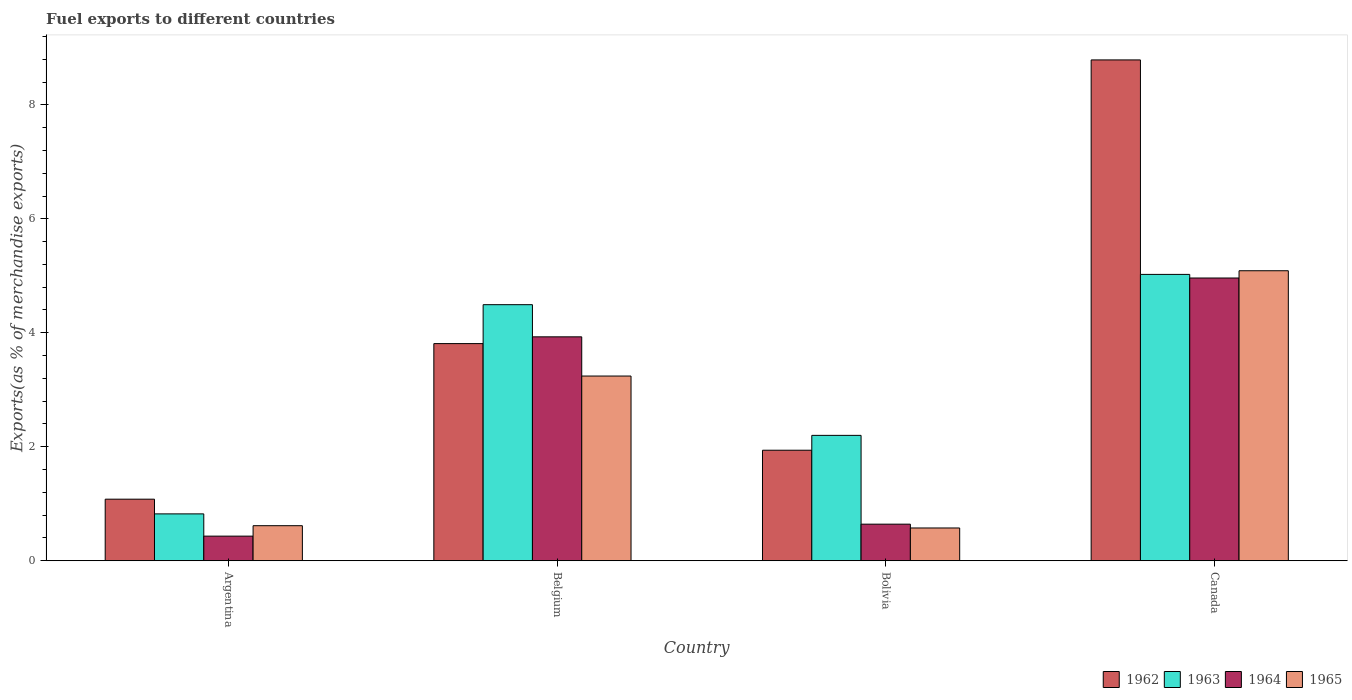How many different coloured bars are there?
Offer a terse response. 4. Are the number of bars per tick equal to the number of legend labels?
Make the answer very short. Yes. Are the number of bars on each tick of the X-axis equal?
Keep it short and to the point. Yes. How many bars are there on the 1st tick from the right?
Provide a succinct answer. 4. What is the percentage of exports to different countries in 1964 in Belgium?
Make the answer very short. 3.93. Across all countries, what is the maximum percentage of exports to different countries in 1963?
Your answer should be very brief. 5.02. Across all countries, what is the minimum percentage of exports to different countries in 1964?
Give a very brief answer. 0.43. In which country was the percentage of exports to different countries in 1964 minimum?
Provide a succinct answer. Argentina. What is the total percentage of exports to different countries in 1965 in the graph?
Your response must be concise. 9.52. What is the difference between the percentage of exports to different countries in 1962 in Argentina and that in Belgium?
Provide a succinct answer. -2.73. What is the difference between the percentage of exports to different countries in 1962 in Belgium and the percentage of exports to different countries in 1963 in Bolivia?
Your answer should be compact. 1.61. What is the average percentage of exports to different countries in 1964 per country?
Give a very brief answer. 2.49. What is the difference between the percentage of exports to different countries of/in 1962 and percentage of exports to different countries of/in 1963 in Bolivia?
Your answer should be compact. -0.26. What is the ratio of the percentage of exports to different countries in 1963 in Argentina to that in Bolivia?
Provide a succinct answer. 0.37. Is the percentage of exports to different countries in 1962 in Belgium less than that in Canada?
Offer a very short reply. Yes. What is the difference between the highest and the second highest percentage of exports to different countries in 1962?
Your response must be concise. 6.85. What is the difference between the highest and the lowest percentage of exports to different countries in 1963?
Your answer should be very brief. 4.2. In how many countries, is the percentage of exports to different countries in 1962 greater than the average percentage of exports to different countries in 1962 taken over all countries?
Make the answer very short. 1. Is the sum of the percentage of exports to different countries in 1965 in Argentina and Belgium greater than the maximum percentage of exports to different countries in 1964 across all countries?
Offer a terse response. No. Is it the case that in every country, the sum of the percentage of exports to different countries in 1964 and percentage of exports to different countries in 1962 is greater than the sum of percentage of exports to different countries in 1965 and percentage of exports to different countries in 1963?
Your answer should be compact. No. What does the 3rd bar from the left in Belgium represents?
Provide a succinct answer. 1964. What does the 2nd bar from the right in Bolivia represents?
Offer a terse response. 1964. Is it the case that in every country, the sum of the percentage of exports to different countries in 1962 and percentage of exports to different countries in 1965 is greater than the percentage of exports to different countries in 1964?
Your answer should be compact. Yes. How many bars are there?
Your answer should be compact. 16. Are all the bars in the graph horizontal?
Give a very brief answer. No. How many countries are there in the graph?
Offer a very short reply. 4. What is the difference between two consecutive major ticks on the Y-axis?
Keep it short and to the point. 2. Are the values on the major ticks of Y-axis written in scientific E-notation?
Your response must be concise. No. Does the graph contain grids?
Offer a very short reply. No. How many legend labels are there?
Provide a short and direct response. 4. How are the legend labels stacked?
Provide a short and direct response. Horizontal. What is the title of the graph?
Give a very brief answer. Fuel exports to different countries. What is the label or title of the X-axis?
Your answer should be compact. Country. What is the label or title of the Y-axis?
Ensure brevity in your answer.  Exports(as % of merchandise exports). What is the Exports(as % of merchandise exports) in 1962 in Argentina?
Provide a short and direct response. 1.08. What is the Exports(as % of merchandise exports) in 1963 in Argentina?
Your response must be concise. 0.82. What is the Exports(as % of merchandise exports) of 1964 in Argentina?
Ensure brevity in your answer.  0.43. What is the Exports(as % of merchandise exports) of 1965 in Argentina?
Keep it short and to the point. 0.62. What is the Exports(as % of merchandise exports) of 1962 in Belgium?
Keep it short and to the point. 3.81. What is the Exports(as % of merchandise exports) of 1963 in Belgium?
Provide a succinct answer. 4.49. What is the Exports(as % of merchandise exports) in 1964 in Belgium?
Give a very brief answer. 3.93. What is the Exports(as % of merchandise exports) in 1965 in Belgium?
Make the answer very short. 3.24. What is the Exports(as % of merchandise exports) in 1962 in Bolivia?
Provide a succinct answer. 1.94. What is the Exports(as % of merchandise exports) in 1963 in Bolivia?
Your answer should be very brief. 2.2. What is the Exports(as % of merchandise exports) of 1964 in Bolivia?
Your answer should be compact. 0.64. What is the Exports(as % of merchandise exports) in 1965 in Bolivia?
Provide a short and direct response. 0.58. What is the Exports(as % of merchandise exports) in 1962 in Canada?
Provide a short and direct response. 8.79. What is the Exports(as % of merchandise exports) of 1963 in Canada?
Provide a short and direct response. 5.02. What is the Exports(as % of merchandise exports) in 1964 in Canada?
Provide a succinct answer. 4.96. What is the Exports(as % of merchandise exports) in 1965 in Canada?
Provide a succinct answer. 5.09. Across all countries, what is the maximum Exports(as % of merchandise exports) of 1962?
Give a very brief answer. 8.79. Across all countries, what is the maximum Exports(as % of merchandise exports) in 1963?
Offer a terse response. 5.02. Across all countries, what is the maximum Exports(as % of merchandise exports) in 1964?
Your answer should be very brief. 4.96. Across all countries, what is the maximum Exports(as % of merchandise exports) of 1965?
Make the answer very short. 5.09. Across all countries, what is the minimum Exports(as % of merchandise exports) of 1962?
Provide a succinct answer. 1.08. Across all countries, what is the minimum Exports(as % of merchandise exports) of 1963?
Provide a short and direct response. 0.82. Across all countries, what is the minimum Exports(as % of merchandise exports) in 1964?
Offer a very short reply. 0.43. Across all countries, what is the minimum Exports(as % of merchandise exports) of 1965?
Offer a very short reply. 0.58. What is the total Exports(as % of merchandise exports) of 1962 in the graph?
Ensure brevity in your answer.  15.62. What is the total Exports(as % of merchandise exports) in 1963 in the graph?
Provide a short and direct response. 12.54. What is the total Exports(as % of merchandise exports) in 1964 in the graph?
Offer a very short reply. 9.97. What is the total Exports(as % of merchandise exports) of 1965 in the graph?
Provide a succinct answer. 9.52. What is the difference between the Exports(as % of merchandise exports) of 1962 in Argentina and that in Belgium?
Offer a very short reply. -2.73. What is the difference between the Exports(as % of merchandise exports) of 1963 in Argentina and that in Belgium?
Your answer should be compact. -3.67. What is the difference between the Exports(as % of merchandise exports) of 1964 in Argentina and that in Belgium?
Provide a succinct answer. -3.5. What is the difference between the Exports(as % of merchandise exports) of 1965 in Argentina and that in Belgium?
Offer a terse response. -2.63. What is the difference between the Exports(as % of merchandise exports) in 1962 in Argentina and that in Bolivia?
Provide a succinct answer. -0.86. What is the difference between the Exports(as % of merchandise exports) in 1963 in Argentina and that in Bolivia?
Your answer should be compact. -1.38. What is the difference between the Exports(as % of merchandise exports) of 1964 in Argentina and that in Bolivia?
Offer a terse response. -0.21. What is the difference between the Exports(as % of merchandise exports) in 1965 in Argentina and that in Bolivia?
Give a very brief answer. 0.04. What is the difference between the Exports(as % of merchandise exports) in 1962 in Argentina and that in Canada?
Provide a succinct answer. -7.71. What is the difference between the Exports(as % of merchandise exports) of 1963 in Argentina and that in Canada?
Provide a short and direct response. -4.2. What is the difference between the Exports(as % of merchandise exports) of 1964 in Argentina and that in Canada?
Offer a very short reply. -4.53. What is the difference between the Exports(as % of merchandise exports) of 1965 in Argentina and that in Canada?
Your answer should be compact. -4.47. What is the difference between the Exports(as % of merchandise exports) in 1962 in Belgium and that in Bolivia?
Provide a short and direct response. 1.87. What is the difference between the Exports(as % of merchandise exports) of 1963 in Belgium and that in Bolivia?
Make the answer very short. 2.29. What is the difference between the Exports(as % of merchandise exports) of 1964 in Belgium and that in Bolivia?
Provide a short and direct response. 3.29. What is the difference between the Exports(as % of merchandise exports) of 1965 in Belgium and that in Bolivia?
Offer a terse response. 2.67. What is the difference between the Exports(as % of merchandise exports) in 1962 in Belgium and that in Canada?
Your response must be concise. -4.98. What is the difference between the Exports(as % of merchandise exports) of 1963 in Belgium and that in Canada?
Offer a terse response. -0.53. What is the difference between the Exports(as % of merchandise exports) of 1964 in Belgium and that in Canada?
Provide a short and direct response. -1.03. What is the difference between the Exports(as % of merchandise exports) in 1965 in Belgium and that in Canada?
Give a very brief answer. -1.85. What is the difference between the Exports(as % of merchandise exports) of 1962 in Bolivia and that in Canada?
Keep it short and to the point. -6.85. What is the difference between the Exports(as % of merchandise exports) of 1963 in Bolivia and that in Canada?
Ensure brevity in your answer.  -2.82. What is the difference between the Exports(as % of merchandise exports) of 1964 in Bolivia and that in Canada?
Give a very brief answer. -4.32. What is the difference between the Exports(as % of merchandise exports) of 1965 in Bolivia and that in Canada?
Offer a terse response. -4.51. What is the difference between the Exports(as % of merchandise exports) of 1962 in Argentina and the Exports(as % of merchandise exports) of 1963 in Belgium?
Provide a short and direct response. -3.41. What is the difference between the Exports(as % of merchandise exports) of 1962 in Argentina and the Exports(as % of merchandise exports) of 1964 in Belgium?
Keep it short and to the point. -2.85. What is the difference between the Exports(as % of merchandise exports) of 1962 in Argentina and the Exports(as % of merchandise exports) of 1965 in Belgium?
Keep it short and to the point. -2.16. What is the difference between the Exports(as % of merchandise exports) in 1963 in Argentina and the Exports(as % of merchandise exports) in 1964 in Belgium?
Ensure brevity in your answer.  -3.11. What is the difference between the Exports(as % of merchandise exports) in 1963 in Argentina and the Exports(as % of merchandise exports) in 1965 in Belgium?
Provide a succinct answer. -2.42. What is the difference between the Exports(as % of merchandise exports) of 1964 in Argentina and the Exports(as % of merchandise exports) of 1965 in Belgium?
Provide a succinct answer. -2.81. What is the difference between the Exports(as % of merchandise exports) in 1962 in Argentina and the Exports(as % of merchandise exports) in 1963 in Bolivia?
Offer a very short reply. -1.12. What is the difference between the Exports(as % of merchandise exports) in 1962 in Argentina and the Exports(as % of merchandise exports) in 1964 in Bolivia?
Give a very brief answer. 0.44. What is the difference between the Exports(as % of merchandise exports) in 1962 in Argentina and the Exports(as % of merchandise exports) in 1965 in Bolivia?
Your answer should be compact. 0.51. What is the difference between the Exports(as % of merchandise exports) of 1963 in Argentina and the Exports(as % of merchandise exports) of 1964 in Bolivia?
Keep it short and to the point. 0.18. What is the difference between the Exports(as % of merchandise exports) of 1963 in Argentina and the Exports(as % of merchandise exports) of 1965 in Bolivia?
Make the answer very short. 0.25. What is the difference between the Exports(as % of merchandise exports) of 1964 in Argentina and the Exports(as % of merchandise exports) of 1965 in Bolivia?
Give a very brief answer. -0.14. What is the difference between the Exports(as % of merchandise exports) of 1962 in Argentina and the Exports(as % of merchandise exports) of 1963 in Canada?
Make the answer very short. -3.94. What is the difference between the Exports(as % of merchandise exports) in 1962 in Argentina and the Exports(as % of merchandise exports) in 1964 in Canada?
Provide a short and direct response. -3.88. What is the difference between the Exports(as % of merchandise exports) in 1962 in Argentina and the Exports(as % of merchandise exports) in 1965 in Canada?
Offer a terse response. -4.01. What is the difference between the Exports(as % of merchandise exports) of 1963 in Argentina and the Exports(as % of merchandise exports) of 1964 in Canada?
Give a very brief answer. -4.14. What is the difference between the Exports(as % of merchandise exports) of 1963 in Argentina and the Exports(as % of merchandise exports) of 1965 in Canada?
Make the answer very short. -4.27. What is the difference between the Exports(as % of merchandise exports) in 1964 in Argentina and the Exports(as % of merchandise exports) in 1965 in Canada?
Make the answer very short. -4.66. What is the difference between the Exports(as % of merchandise exports) of 1962 in Belgium and the Exports(as % of merchandise exports) of 1963 in Bolivia?
Provide a short and direct response. 1.61. What is the difference between the Exports(as % of merchandise exports) in 1962 in Belgium and the Exports(as % of merchandise exports) in 1964 in Bolivia?
Your response must be concise. 3.17. What is the difference between the Exports(as % of merchandise exports) in 1962 in Belgium and the Exports(as % of merchandise exports) in 1965 in Bolivia?
Offer a very short reply. 3.23. What is the difference between the Exports(as % of merchandise exports) in 1963 in Belgium and the Exports(as % of merchandise exports) in 1964 in Bolivia?
Provide a succinct answer. 3.85. What is the difference between the Exports(as % of merchandise exports) in 1963 in Belgium and the Exports(as % of merchandise exports) in 1965 in Bolivia?
Give a very brief answer. 3.92. What is the difference between the Exports(as % of merchandise exports) in 1964 in Belgium and the Exports(as % of merchandise exports) in 1965 in Bolivia?
Provide a short and direct response. 3.35. What is the difference between the Exports(as % of merchandise exports) in 1962 in Belgium and the Exports(as % of merchandise exports) in 1963 in Canada?
Provide a short and direct response. -1.21. What is the difference between the Exports(as % of merchandise exports) of 1962 in Belgium and the Exports(as % of merchandise exports) of 1964 in Canada?
Offer a very short reply. -1.15. What is the difference between the Exports(as % of merchandise exports) of 1962 in Belgium and the Exports(as % of merchandise exports) of 1965 in Canada?
Offer a very short reply. -1.28. What is the difference between the Exports(as % of merchandise exports) of 1963 in Belgium and the Exports(as % of merchandise exports) of 1964 in Canada?
Give a very brief answer. -0.47. What is the difference between the Exports(as % of merchandise exports) of 1963 in Belgium and the Exports(as % of merchandise exports) of 1965 in Canada?
Keep it short and to the point. -0.6. What is the difference between the Exports(as % of merchandise exports) in 1964 in Belgium and the Exports(as % of merchandise exports) in 1965 in Canada?
Your answer should be compact. -1.16. What is the difference between the Exports(as % of merchandise exports) in 1962 in Bolivia and the Exports(as % of merchandise exports) in 1963 in Canada?
Offer a terse response. -3.08. What is the difference between the Exports(as % of merchandise exports) in 1962 in Bolivia and the Exports(as % of merchandise exports) in 1964 in Canada?
Your answer should be compact. -3.02. What is the difference between the Exports(as % of merchandise exports) of 1962 in Bolivia and the Exports(as % of merchandise exports) of 1965 in Canada?
Provide a succinct answer. -3.15. What is the difference between the Exports(as % of merchandise exports) in 1963 in Bolivia and the Exports(as % of merchandise exports) in 1964 in Canada?
Keep it short and to the point. -2.76. What is the difference between the Exports(as % of merchandise exports) of 1963 in Bolivia and the Exports(as % of merchandise exports) of 1965 in Canada?
Your answer should be very brief. -2.89. What is the difference between the Exports(as % of merchandise exports) in 1964 in Bolivia and the Exports(as % of merchandise exports) in 1965 in Canada?
Give a very brief answer. -4.45. What is the average Exports(as % of merchandise exports) in 1962 per country?
Offer a very short reply. 3.9. What is the average Exports(as % of merchandise exports) in 1963 per country?
Your answer should be compact. 3.14. What is the average Exports(as % of merchandise exports) of 1964 per country?
Give a very brief answer. 2.49. What is the average Exports(as % of merchandise exports) of 1965 per country?
Keep it short and to the point. 2.38. What is the difference between the Exports(as % of merchandise exports) of 1962 and Exports(as % of merchandise exports) of 1963 in Argentina?
Your response must be concise. 0.26. What is the difference between the Exports(as % of merchandise exports) in 1962 and Exports(as % of merchandise exports) in 1964 in Argentina?
Offer a terse response. 0.65. What is the difference between the Exports(as % of merchandise exports) of 1962 and Exports(as % of merchandise exports) of 1965 in Argentina?
Your answer should be compact. 0.47. What is the difference between the Exports(as % of merchandise exports) of 1963 and Exports(as % of merchandise exports) of 1964 in Argentina?
Give a very brief answer. 0.39. What is the difference between the Exports(as % of merchandise exports) in 1963 and Exports(as % of merchandise exports) in 1965 in Argentina?
Give a very brief answer. 0.21. What is the difference between the Exports(as % of merchandise exports) of 1964 and Exports(as % of merchandise exports) of 1965 in Argentina?
Provide a succinct answer. -0.18. What is the difference between the Exports(as % of merchandise exports) of 1962 and Exports(as % of merchandise exports) of 1963 in Belgium?
Provide a succinct answer. -0.68. What is the difference between the Exports(as % of merchandise exports) of 1962 and Exports(as % of merchandise exports) of 1964 in Belgium?
Provide a succinct answer. -0.12. What is the difference between the Exports(as % of merchandise exports) in 1962 and Exports(as % of merchandise exports) in 1965 in Belgium?
Ensure brevity in your answer.  0.57. What is the difference between the Exports(as % of merchandise exports) of 1963 and Exports(as % of merchandise exports) of 1964 in Belgium?
Your answer should be compact. 0.56. What is the difference between the Exports(as % of merchandise exports) of 1963 and Exports(as % of merchandise exports) of 1965 in Belgium?
Your answer should be very brief. 1.25. What is the difference between the Exports(as % of merchandise exports) in 1964 and Exports(as % of merchandise exports) in 1965 in Belgium?
Offer a terse response. 0.69. What is the difference between the Exports(as % of merchandise exports) in 1962 and Exports(as % of merchandise exports) in 1963 in Bolivia?
Your answer should be very brief. -0.26. What is the difference between the Exports(as % of merchandise exports) in 1962 and Exports(as % of merchandise exports) in 1964 in Bolivia?
Your answer should be very brief. 1.3. What is the difference between the Exports(as % of merchandise exports) in 1962 and Exports(as % of merchandise exports) in 1965 in Bolivia?
Keep it short and to the point. 1.36. What is the difference between the Exports(as % of merchandise exports) in 1963 and Exports(as % of merchandise exports) in 1964 in Bolivia?
Provide a succinct answer. 1.56. What is the difference between the Exports(as % of merchandise exports) in 1963 and Exports(as % of merchandise exports) in 1965 in Bolivia?
Offer a very short reply. 1.62. What is the difference between the Exports(as % of merchandise exports) in 1964 and Exports(as % of merchandise exports) in 1965 in Bolivia?
Keep it short and to the point. 0.07. What is the difference between the Exports(as % of merchandise exports) in 1962 and Exports(as % of merchandise exports) in 1963 in Canada?
Your answer should be very brief. 3.76. What is the difference between the Exports(as % of merchandise exports) of 1962 and Exports(as % of merchandise exports) of 1964 in Canada?
Your answer should be compact. 3.83. What is the difference between the Exports(as % of merchandise exports) of 1962 and Exports(as % of merchandise exports) of 1965 in Canada?
Offer a very short reply. 3.7. What is the difference between the Exports(as % of merchandise exports) of 1963 and Exports(as % of merchandise exports) of 1964 in Canada?
Offer a very short reply. 0.06. What is the difference between the Exports(as % of merchandise exports) in 1963 and Exports(as % of merchandise exports) in 1965 in Canada?
Offer a terse response. -0.06. What is the difference between the Exports(as % of merchandise exports) in 1964 and Exports(as % of merchandise exports) in 1965 in Canada?
Your answer should be compact. -0.13. What is the ratio of the Exports(as % of merchandise exports) of 1962 in Argentina to that in Belgium?
Offer a very short reply. 0.28. What is the ratio of the Exports(as % of merchandise exports) of 1963 in Argentina to that in Belgium?
Provide a succinct answer. 0.18. What is the ratio of the Exports(as % of merchandise exports) of 1964 in Argentina to that in Belgium?
Ensure brevity in your answer.  0.11. What is the ratio of the Exports(as % of merchandise exports) in 1965 in Argentina to that in Belgium?
Offer a very short reply. 0.19. What is the ratio of the Exports(as % of merchandise exports) in 1962 in Argentina to that in Bolivia?
Provide a succinct answer. 0.56. What is the ratio of the Exports(as % of merchandise exports) in 1963 in Argentina to that in Bolivia?
Your response must be concise. 0.37. What is the ratio of the Exports(as % of merchandise exports) of 1964 in Argentina to that in Bolivia?
Keep it short and to the point. 0.67. What is the ratio of the Exports(as % of merchandise exports) of 1965 in Argentina to that in Bolivia?
Your answer should be very brief. 1.07. What is the ratio of the Exports(as % of merchandise exports) in 1962 in Argentina to that in Canada?
Give a very brief answer. 0.12. What is the ratio of the Exports(as % of merchandise exports) in 1963 in Argentina to that in Canada?
Your answer should be compact. 0.16. What is the ratio of the Exports(as % of merchandise exports) in 1964 in Argentina to that in Canada?
Make the answer very short. 0.09. What is the ratio of the Exports(as % of merchandise exports) in 1965 in Argentina to that in Canada?
Your response must be concise. 0.12. What is the ratio of the Exports(as % of merchandise exports) in 1962 in Belgium to that in Bolivia?
Your answer should be compact. 1.96. What is the ratio of the Exports(as % of merchandise exports) in 1963 in Belgium to that in Bolivia?
Offer a very short reply. 2.04. What is the ratio of the Exports(as % of merchandise exports) in 1964 in Belgium to that in Bolivia?
Your answer should be very brief. 6.12. What is the ratio of the Exports(as % of merchandise exports) of 1965 in Belgium to that in Bolivia?
Your answer should be compact. 5.63. What is the ratio of the Exports(as % of merchandise exports) of 1962 in Belgium to that in Canada?
Make the answer very short. 0.43. What is the ratio of the Exports(as % of merchandise exports) of 1963 in Belgium to that in Canada?
Ensure brevity in your answer.  0.89. What is the ratio of the Exports(as % of merchandise exports) of 1964 in Belgium to that in Canada?
Give a very brief answer. 0.79. What is the ratio of the Exports(as % of merchandise exports) in 1965 in Belgium to that in Canada?
Offer a very short reply. 0.64. What is the ratio of the Exports(as % of merchandise exports) in 1962 in Bolivia to that in Canada?
Give a very brief answer. 0.22. What is the ratio of the Exports(as % of merchandise exports) in 1963 in Bolivia to that in Canada?
Make the answer very short. 0.44. What is the ratio of the Exports(as % of merchandise exports) of 1964 in Bolivia to that in Canada?
Provide a short and direct response. 0.13. What is the ratio of the Exports(as % of merchandise exports) of 1965 in Bolivia to that in Canada?
Make the answer very short. 0.11. What is the difference between the highest and the second highest Exports(as % of merchandise exports) in 1962?
Keep it short and to the point. 4.98. What is the difference between the highest and the second highest Exports(as % of merchandise exports) in 1963?
Offer a terse response. 0.53. What is the difference between the highest and the second highest Exports(as % of merchandise exports) in 1964?
Provide a short and direct response. 1.03. What is the difference between the highest and the second highest Exports(as % of merchandise exports) in 1965?
Give a very brief answer. 1.85. What is the difference between the highest and the lowest Exports(as % of merchandise exports) of 1962?
Offer a terse response. 7.71. What is the difference between the highest and the lowest Exports(as % of merchandise exports) in 1963?
Offer a terse response. 4.2. What is the difference between the highest and the lowest Exports(as % of merchandise exports) of 1964?
Ensure brevity in your answer.  4.53. What is the difference between the highest and the lowest Exports(as % of merchandise exports) of 1965?
Your answer should be very brief. 4.51. 